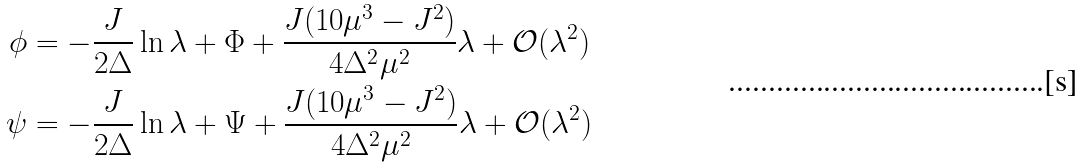Convert formula to latex. <formula><loc_0><loc_0><loc_500><loc_500>\phi & = - \frac { J } { 2 \Delta } \ln \lambda + \Phi + \frac { J ( 1 0 \mu ^ { 3 } - J ^ { 2 } ) } { 4 \Delta ^ { 2 } \mu ^ { 2 } } \lambda + \mathcal { O } ( \lambda ^ { 2 } ) \\ \psi & = - \frac { J } { 2 \Delta } \ln \lambda + \Psi + \frac { J ( 1 0 \mu ^ { 3 } - J ^ { 2 } ) } { 4 \Delta ^ { 2 } \mu ^ { 2 } } \lambda + \mathcal { O } ( \lambda ^ { 2 } )</formula> 